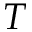Convert formula to latex. <formula><loc_0><loc_0><loc_500><loc_500>T</formula> 